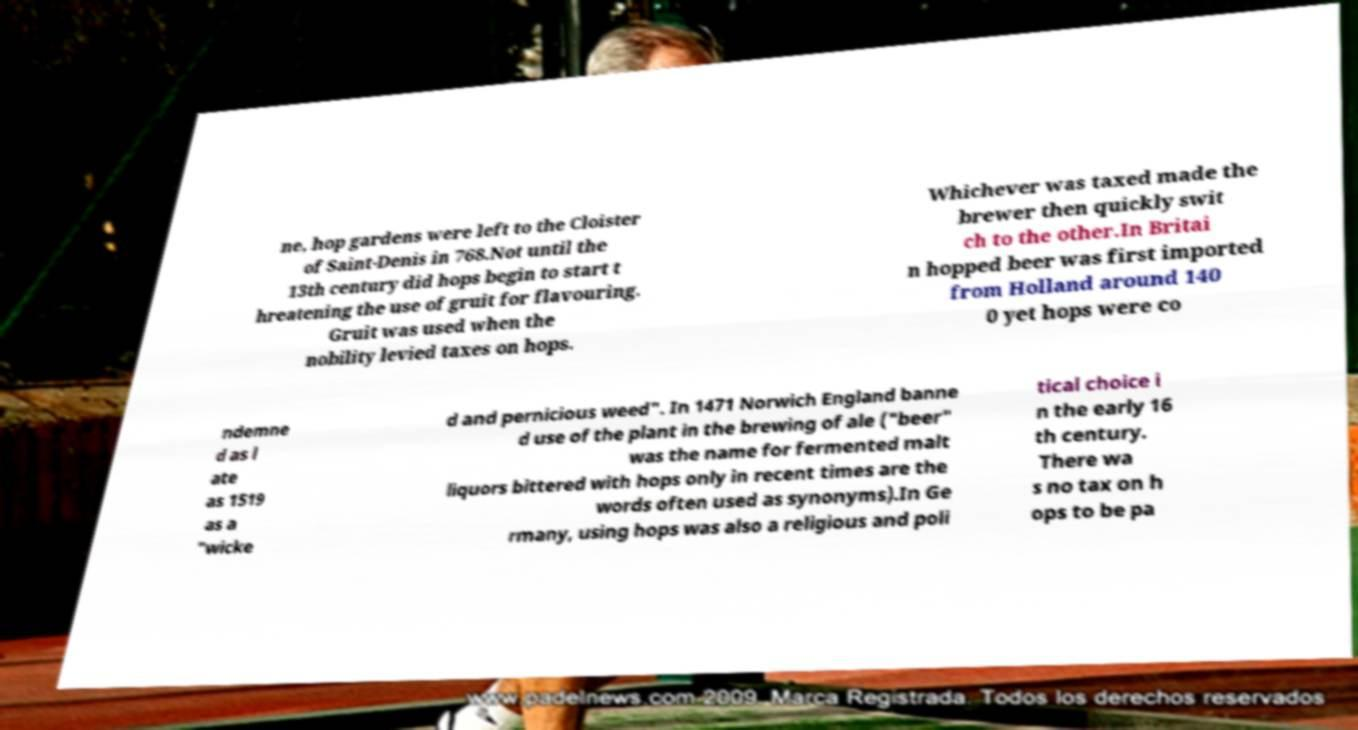Please read and relay the text visible in this image. What does it say? ne, hop gardens were left to the Cloister of Saint-Denis in 768.Not until the 13th century did hops begin to start t hreatening the use of gruit for flavouring. Gruit was used when the nobility levied taxes on hops. Whichever was taxed made the brewer then quickly swit ch to the other.In Britai n hopped beer was first imported from Holland around 140 0 yet hops were co ndemne d as l ate as 1519 as a "wicke d and pernicious weed". In 1471 Norwich England banne d use of the plant in the brewing of ale ("beer" was the name for fermented malt liquors bittered with hops only in recent times are the words often used as synonyms).In Ge rmany, using hops was also a religious and poli tical choice i n the early 16 th century. There wa s no tax on h ops to be pa 